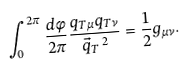Convert formula to latex. <formula><loc_0><loc_0><loc_500><loc_500>\int _ { 0 } ^ { 2 \pi } \frac { d \phi } { 2 \pi } \frac { q _ { T \mu } q _ { T \nu } } { \vec { q } _ { T } \, ^ { 2 } } = \frac { 1 } { 2 } g _ { \mu \nu } .</formula> 